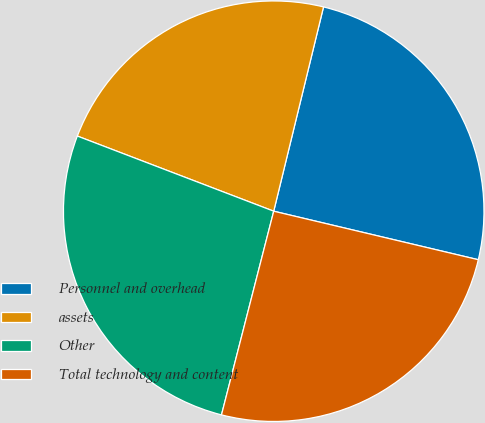Convert chart. <chart><loc_0><loc_0><loc_500><loc_500><pie_chart><fcel>Personnel and overhead<fcel>assets<fcel>Other<fcel>Total technology and content<nl><fcel>24.9%<fcel>22.99%<fcel>26.82%<fcel>25.29%<nl></chart> 